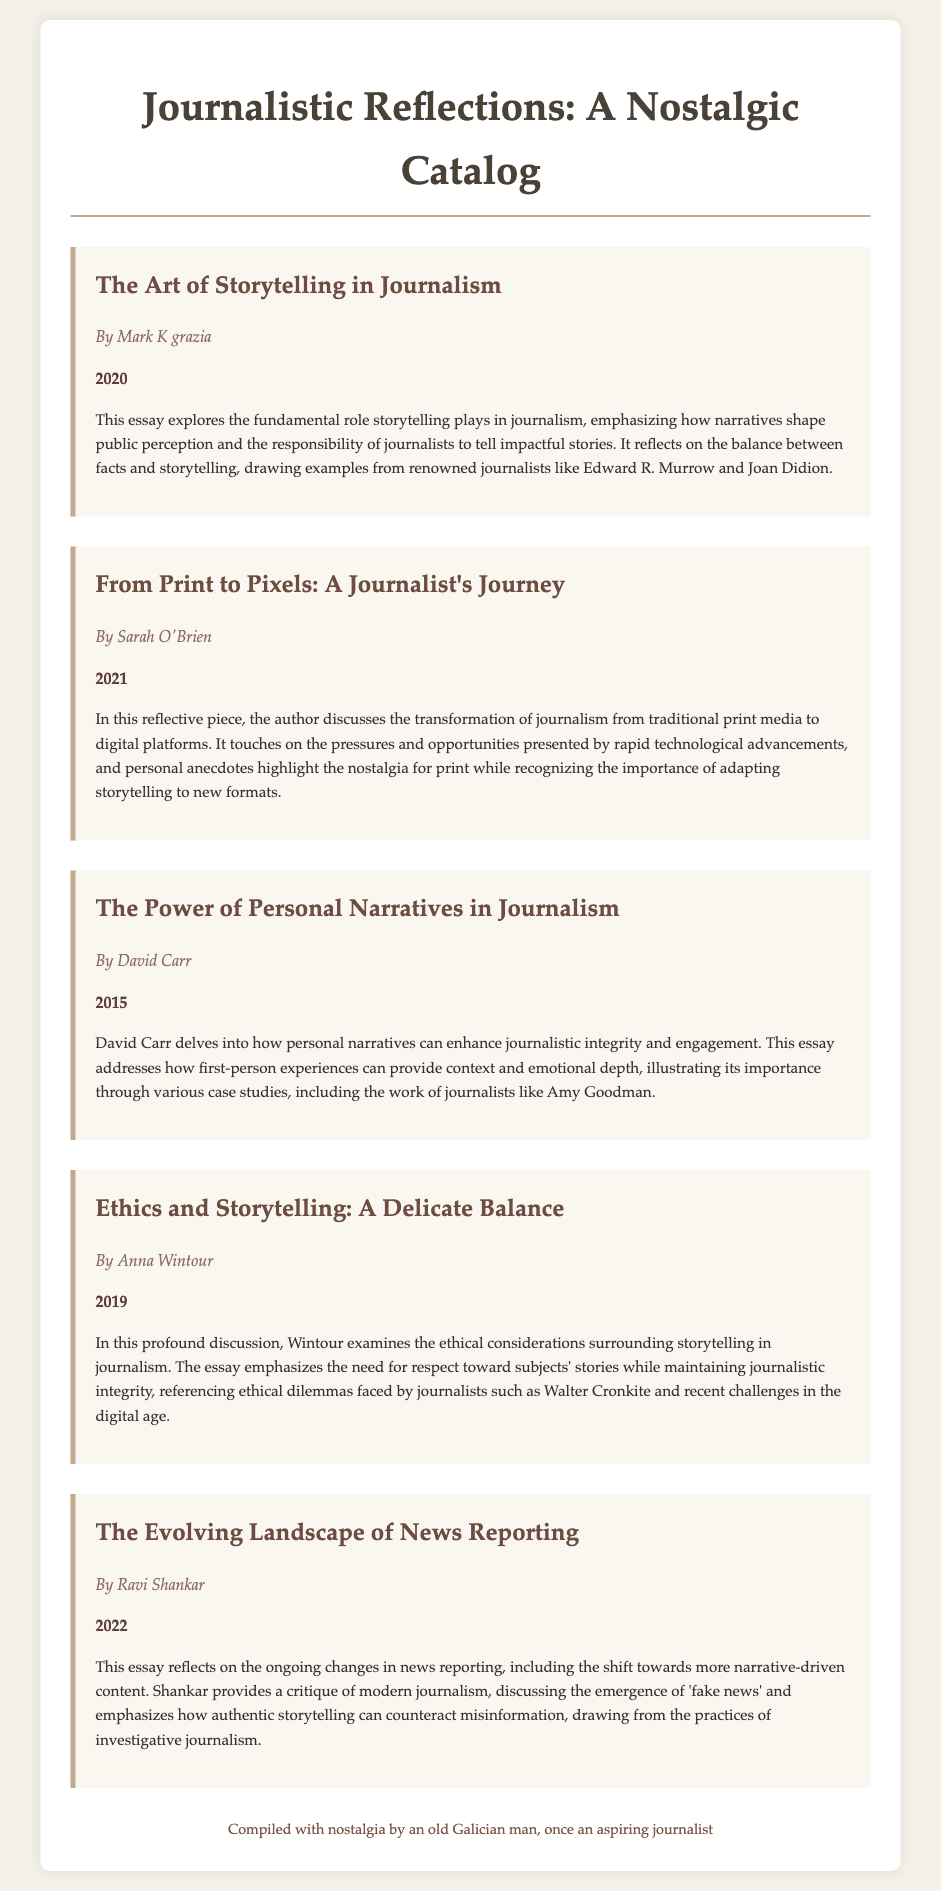What is the title of the first catalog item? The title of the first catalog item is specified in the document and is "The Art of Storytelling in Journalism."
Answer: The Art of Storytelling in Journalism Who is the author of the second essay? The author of the second essay is mentioned as "Sarah O'Brien" in the document.
Answer: Sarah O'Brien What year was "The Power of Personal Narratives in Journalism" published? The year of publication for "The Power of Personal Narratives in Journalism" is listed as 2015 in the document.
Answer: 2015 Which journalist's work is mentioned in relation to ethics and storytelling? The document notes Walter Cronkite in the context of ethics and storytelling.
Answer: Walter Cronkite What theme is addressed in Ravi Shankar's essay? Ravi Shankar's essay addresses the theme of the evolving landscape of news reporting and authentic storytelling.
Answer: Evolving landscape of news reporting How does storytelling influence public perception? The document states that storytelling shapes public perception and highlights its importance in journalism.
Answer: It shapes public perception What is the secondary focus of David Carr's essay? In addition to personal narratives, David Carr's essay discusses enhancing journalistic integrity and engagement through context and emotional depth.
Answer: Enhancing journalistic integrity How many essays are included in the catalog? The document lists five essays in total within the catalog.
Answer: Five essays What type of document is this? The document is a catalog that compiles personal reflections and essays on journalism.
Answer: Catalog 